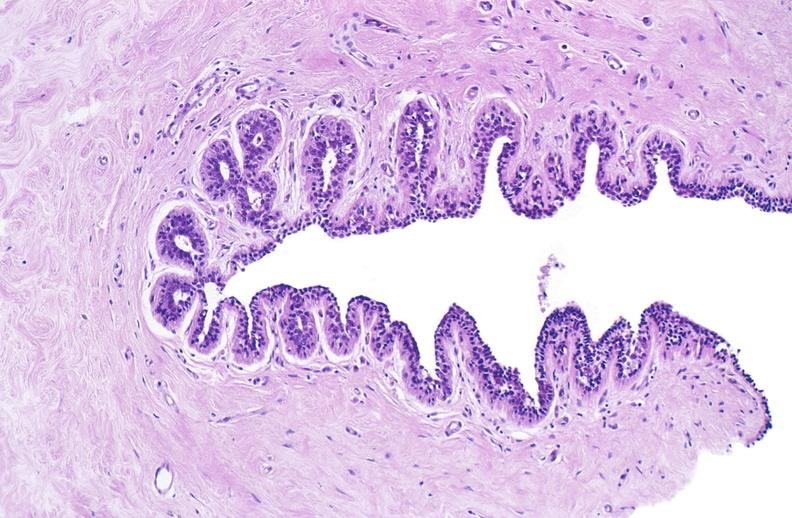does fibrinous peritonitis show normal breast?
Answer the question using a single word or phrase. No 